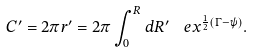Convert formula to latex. <formula><loc_0><loc_0><loc_500><loc_500>C ^ { \prime } = 2 \pi r ^ { \prime } = 2 \pi \int ^ { R } _ { 0 } d R ^ { \prime } \ \ e x ^ { \frac { 1 } { 2 } ( \Gamma - \psi ) } .</formula> 